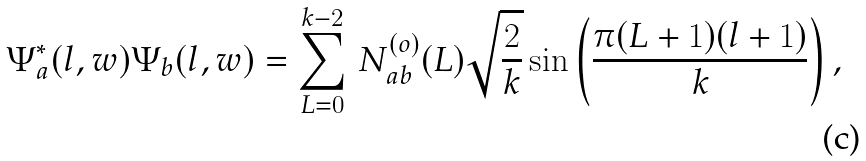<formula> <loc_0><loc_0><loc_500><loc_500>\Psi _ { a } ^ { * } ( l , w ) \Psi _ { b } ( l , w ) = \sum _ { L = 0 } ^ { k - 2 } \, N ^ { ( o ) } _ { a b } ( L ) \sqrt { \frac { 2 } { k } } \sin \left ( \frac { \pi ( L + 1 ) ( l + 1 ) } { k } \right ) ,</formula> 